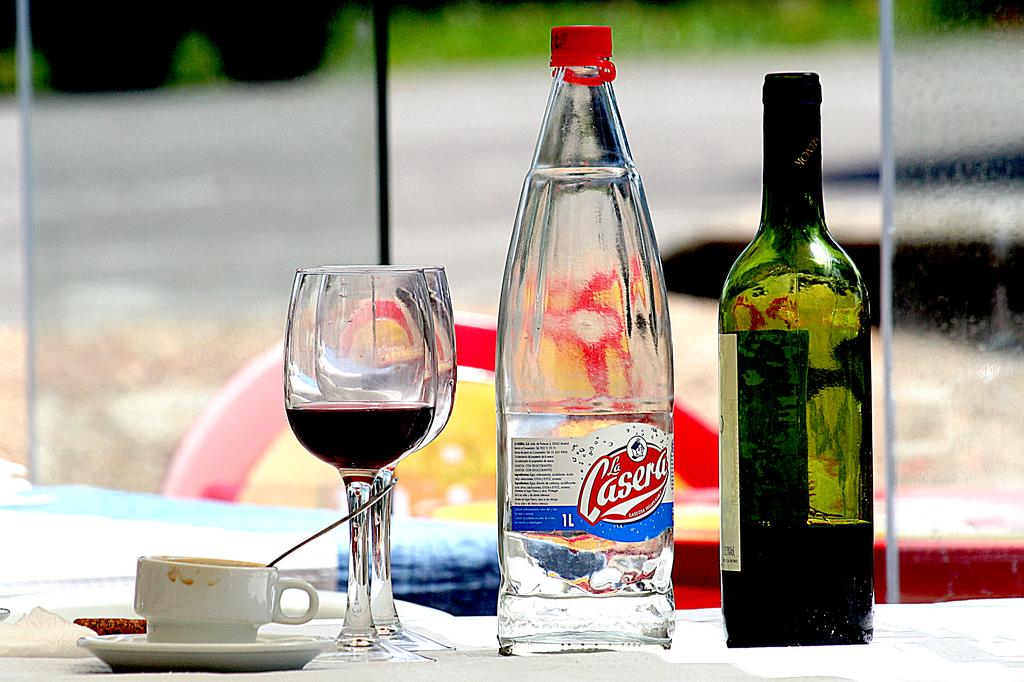What type of container is visible in the image? There is a cup in the image. Are there any other containers present in the image? Yes, there are glasses in the image. How many bottles can be seen in the image? There are two bottles in the image. What type of park is visible in the image? There is no park present in the image; the image only contains cups, glasses, and bottles. What color is the marble in the image? There is no marble present in the image. 